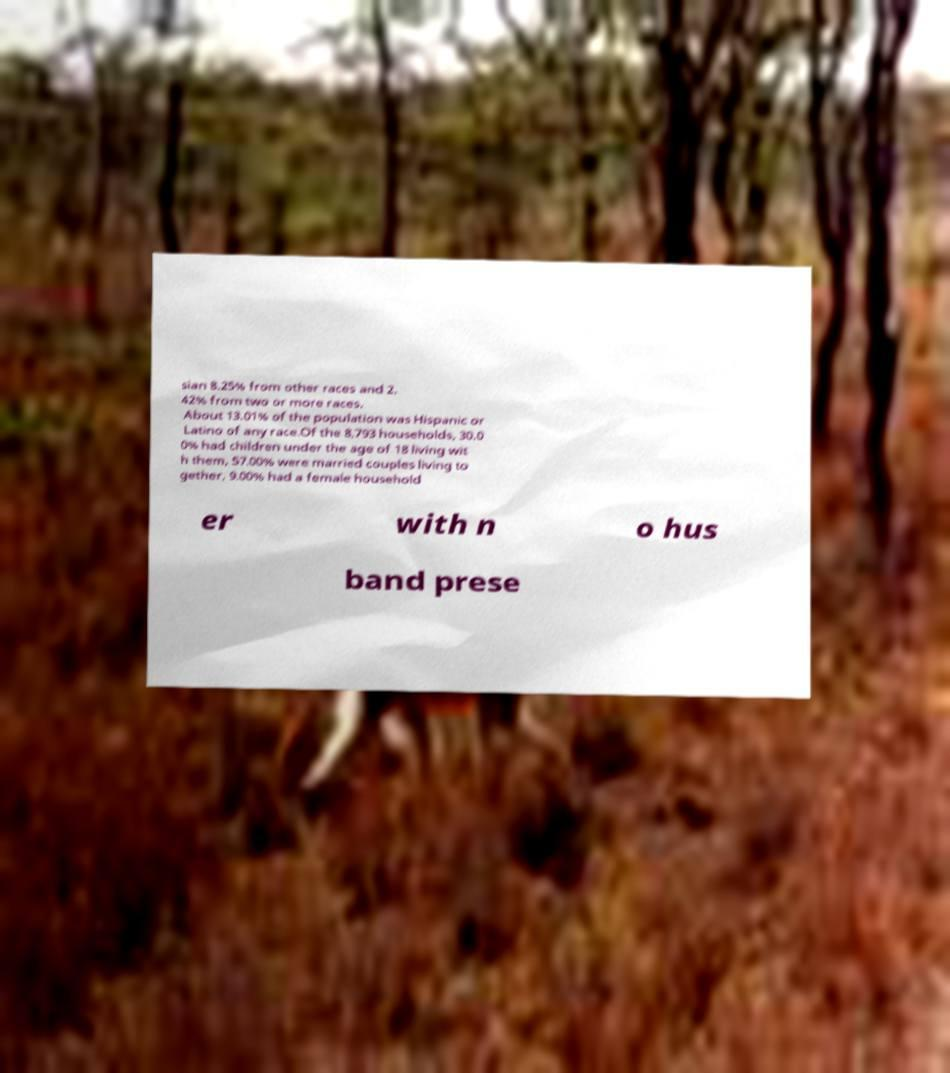Could you extract and type out the text from this image? sian 8.25% from other races and 2. 42% from two or more races. About 13.01% of the population was Hispanic or Latino of any race.Of the 8,793 households, 30.0 0% had children under the age of 18 living wit h them, 57.00% were married couples living to gether, 9.00% had a female household er with n o hus band prese 